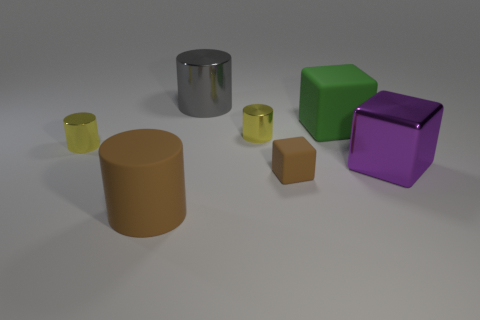Is the number of gray objects on the right side of the big green thing greater than the number of metallic things behind the purple cube?
Give a very brief answer. No. The rubber cylinder is what size?
Give a very brief answer. Large. Are there any green rubber things that have the same shape as the big purple metal object?
Your answer should be very brief. Yes. Does the large brown matte object have the same shape as the big matte object that is right of the tiny brown rubber block?
Give a very brief answer. No. What is the size of the metal cylinder that is right of the big matte cylinder and in front of the gray shiny thing?
Ensure brevity in your answer.  Small. How many big yellow metallic blocks are there?
Your response must be concise. 0. There is a gray thing that is the same size as the brown cylinder; what is its material?
Keep it short and to the point. Metal. Is there a gray cylinder of the same size as the green rubber object?
Offer a terse response. Yes. Do the object that is on the left side of the brown matte cylinder and the matte object behind the big metallic cube have the same color?
Your answer should be very brief. No. What number of rubber objects are either purple cubes or blue balls?
Offer a terse response. 0. 